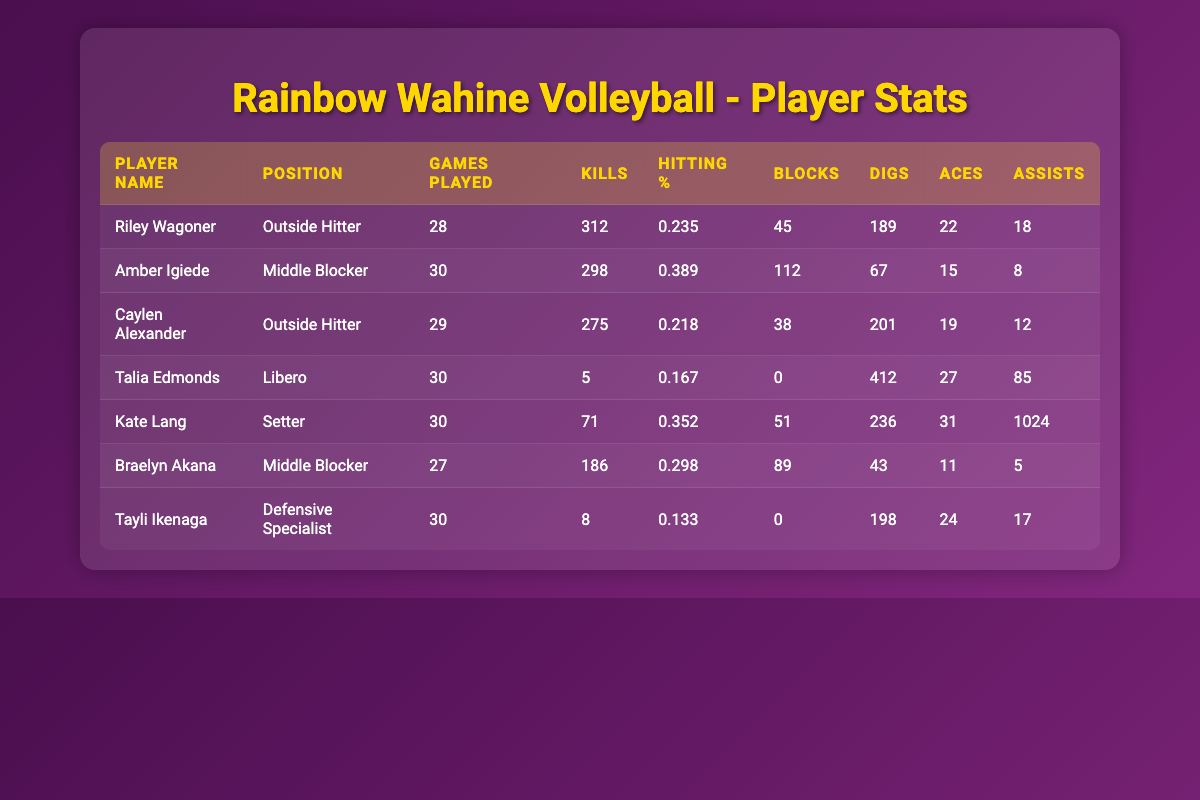What is the player with the most kills? Reviewing the "Kills" column in the table, Amber Igiede has the highest number of kills with a total of 298.
Answer: Amber Igiede Which player has the highest hitting percentage? Checking the "Hitting %" column, Amber Igiede also has the highest hitting percentage at 0.389.
Answer: Amber Igiede What is the total number of blocks by the team’s middle blockers? The middle blockers are Amber Igiede and Braelyn Akana. Their blocks are 112 and 89 respectively. Therefore, total blocks = 112 + 89 = 201.
Answer: 201 How many games did Caylen Alexander play? Looking at the "Games Played" column, Caylen Alexander played 29 games.
Answer: 29 Is Talia Edmonds the libero with the most digs? The entry in the "Digs" column shows Talia Edmonds has 412 digs, which is indeed the highest among all players listed.
Answer: Yes What is Kate Lang's total contribution in assists and aces combined? Kate Lang has 1024 assists and 31 aces. Adding these gives 1024 + 31 = 1055.
Answer: 1055 Which outside hitter has the lowest hitting percentage? The "Hitting %" column shows that Riley Wagoner has a hitting percentage of 0.235, while Caylen Alexander has 0.218. Therefore, Caylen Alexander is the one with the lowest.
Answer: Caylen Alexander What is the average number of digs among the starting lineup? The total digs are 189 + 67 + 201 + 412 + 236 + 43 + 198 = 1346. There are 7 players in total, so the average is 1346 / 7 ≈ 192.29.
Answer: 192.29 How does the performance in kills compare between the two outside hitters? Riley Wagoner has 312 kills and Caylen Alexander has 275 kills. Therefore, Riley has 312 - 275 = 37 more kills than Caylen.
Answer: 37 Who has the lowest total of digs in the starting lineup? Comparing the "Digs" column, the lowest total is from Amber Igiede with only 67 digs.
Answer: Amber Igiede 